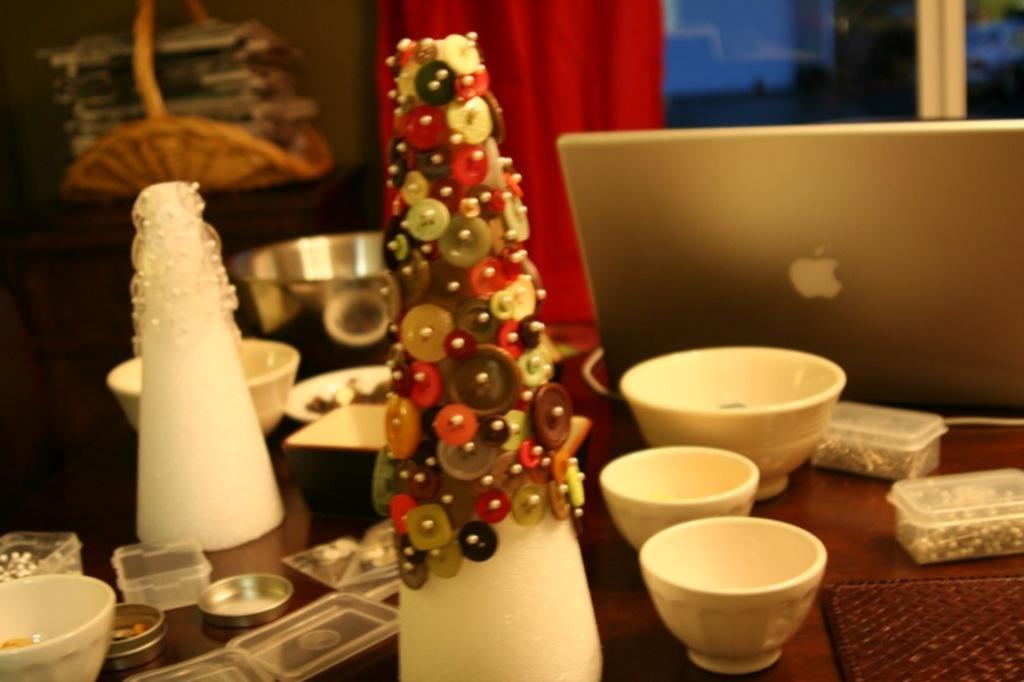Could you give a brief overview of what you see in this image? This image is taken inside a room, in this image there is a table and on top of it there is a box, bowl, plate, cup, sponge and there are few buttons on it, laptop are there on it. In the left side of the image there is a cupboard and top of it there is a basket with few papers in it. In the background there is a wall, window and curtain. 